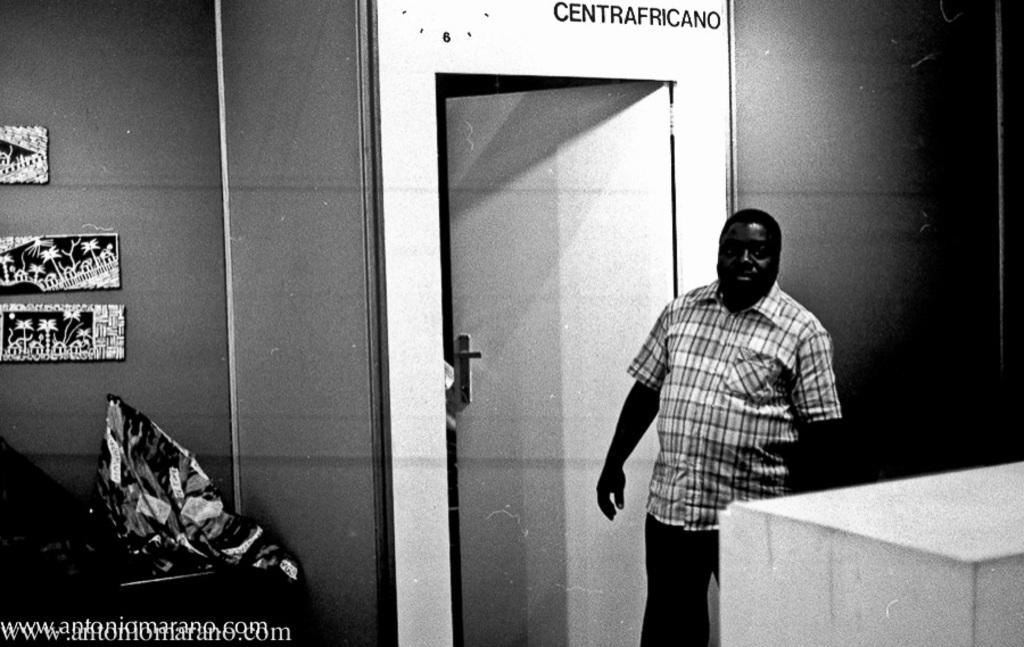What type of image is present in the main subject of the picture? There is a black and white photograph in the image. What is happening in the photograph? The photograph contains a person standing in front of an open door. Are there any additional details visible in the photograph? Yes, there are images on the wall beside the door in the photograph. What type of print is visible on the person's shirt in the image? There is no information about the person's shirt in the provided facts, so we cannot determine if there is a print visible. Is there a chessboard visible in the image? There is no mention of a chessboard in the provided facts, so we cannot determine if one is present. 